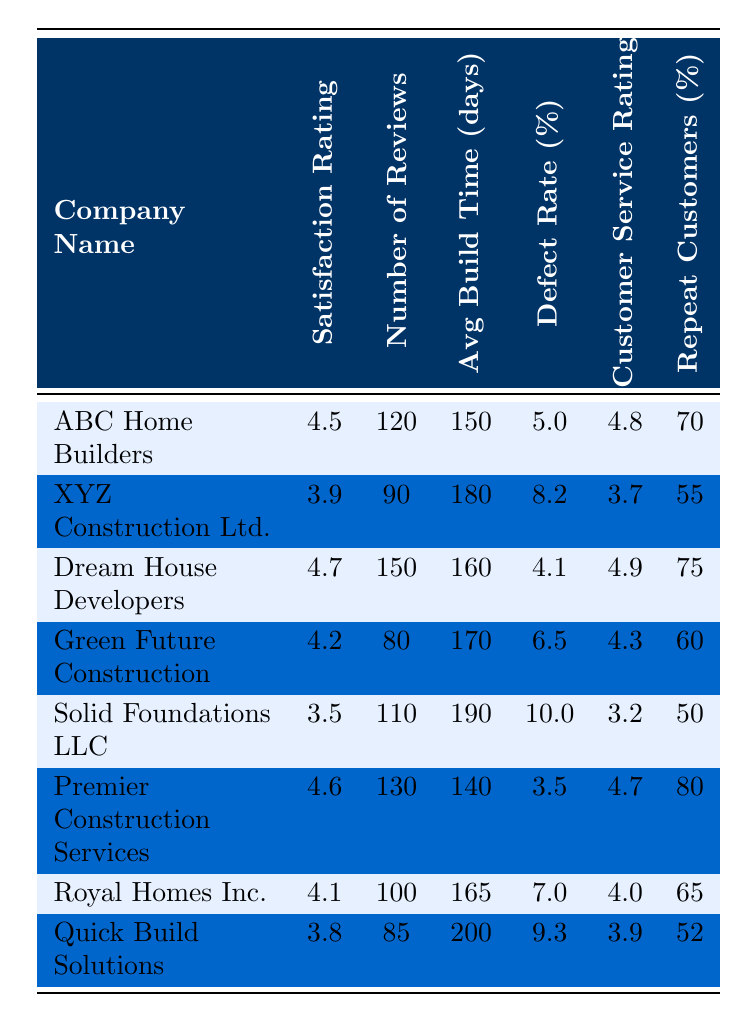What is the satisfaction rating of Premier Construction Services? The satisfaction rating of Premier Construction Services is found in the second column of the table, next to the company name. It shows a rating of 4.6.
Answer: 4.6 Which construction company has the highest number of reviews? By comparing the number of reviews in the table, Dream House Developers has the highest with 150 reviews listed in the third column.
Answer: Dream House Developers What is the average build time for Solid Foundations LLC? The average build time is found in the fourth column next to Solid Foundations LLC, which indicates 190 days.
Answer: 190 days What is the defect rate percentage for Quick Build Solutions? The defect rate percentage for Quick Build Solutions can be found in the fifth column by looking at the corresponding row for the company, which is 9.3%.
Answer: 9.3% Which company has the highest customer service rating? By examining the customer service ratings in the sixth column, Premier Construction Services has the highest rating at 4.7.
Answer: Premier Construction Services Is the satisfaction rating of XYZ Construction Ltd. above 4.0? The satisfaction rating of XYZ Construction Ltd., which is 3.9, can be compared against 4.0, showing that it is below 4.0.
Answer: No Calculate the average satisfaction rating of all the construction companies. To find the average, add all satisfaction ratings: (4.5 + 3.9 + 4.7 + 4.2 + 3.5 + 4.6 + 4.1 + 3.8) = 33.3. Then divide by 8 for the average: 33.3/8 = 4.1625, rounded to two decimal places gives 4.16.
Answer: 4.16 Which company has the lowest repeat customers percentage? Looking at the last column for repeat customers, Solid Foundations LLC has the lowest percentage at 50%.
Answer: Solid Foundations LLC Compare the average build times of the two companies with the highest satisfaction ratings. Each company with the highest satisfaction ratings, Dream House Developers (160 days) and Premier Construction Services (140 days), shows that Premier Construction Services has the shorter build time.
Answer: Premier Construction Services Is there any company with a defect rate of 10% or higher? By checking the defect rates in the fifth column, Solid Foundations LLC has a defect rate of 10.0%, confirming that it meets the criteria.
Answer: Yes 